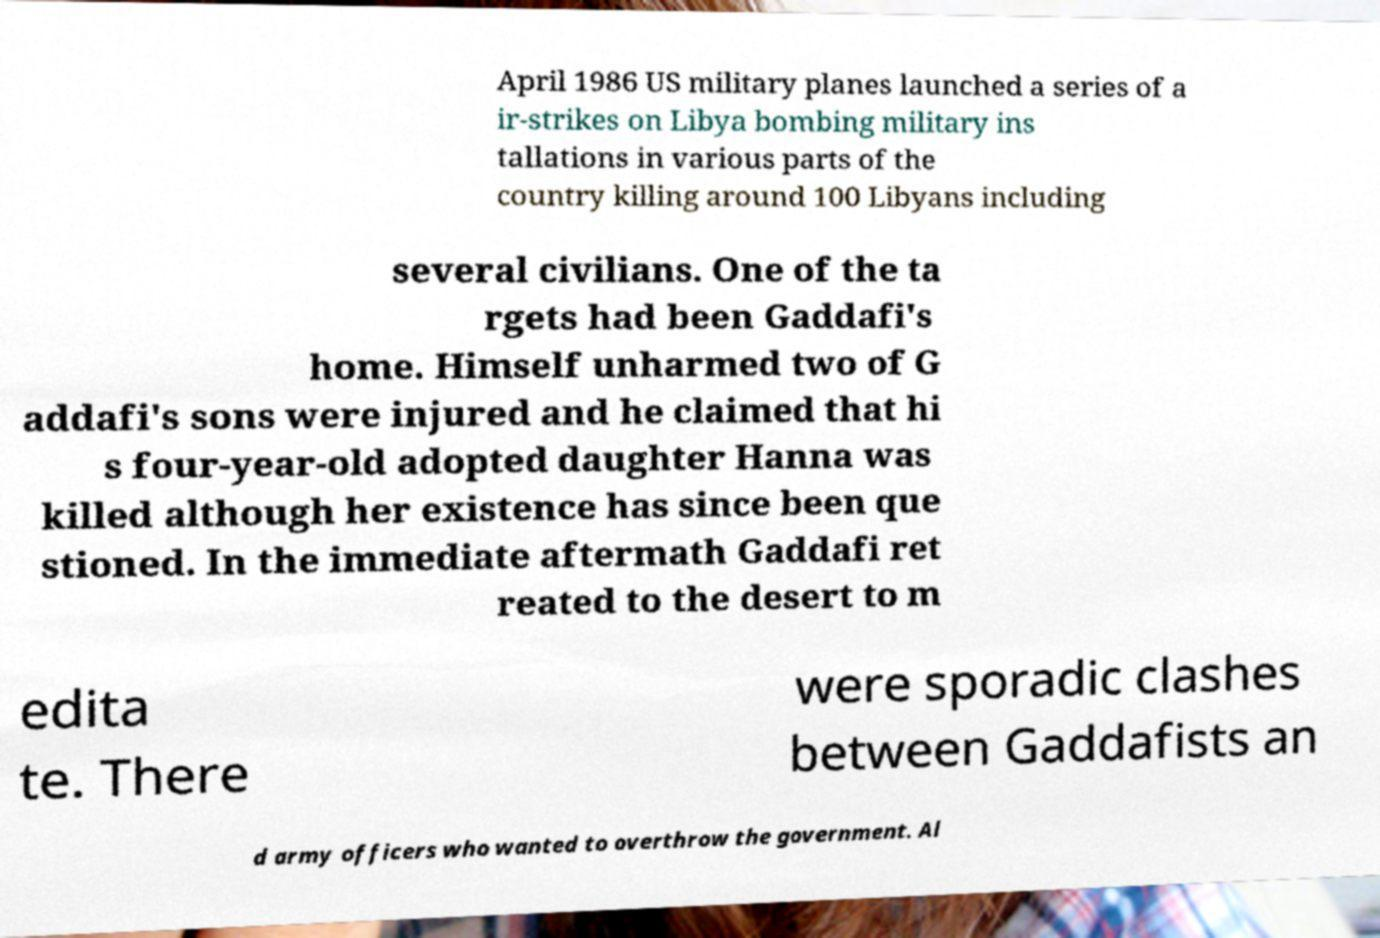Can you read and provide the text displayed in the image?This photo seems to have some interesting text. Can you extract and type it out for me? April 1986 US military planes launched a series of a ir-strikes on Libya bombing military ins tallations in various parts of the country killing around 100 Libyans including several civilians. One of the ta rgets had been Gaddafi's home. Himself unharmed two of G addafi's sons were injured and he claimed that hi s four-year-old adopted daughter Hanna was killed although her existence has since been que stioned. In the immediate aftermath Gaddafi ret reated to the desert to m edita te. There were sporadic clashes between Gaddafists an d army officers who wanted to overthrow the government. Al 